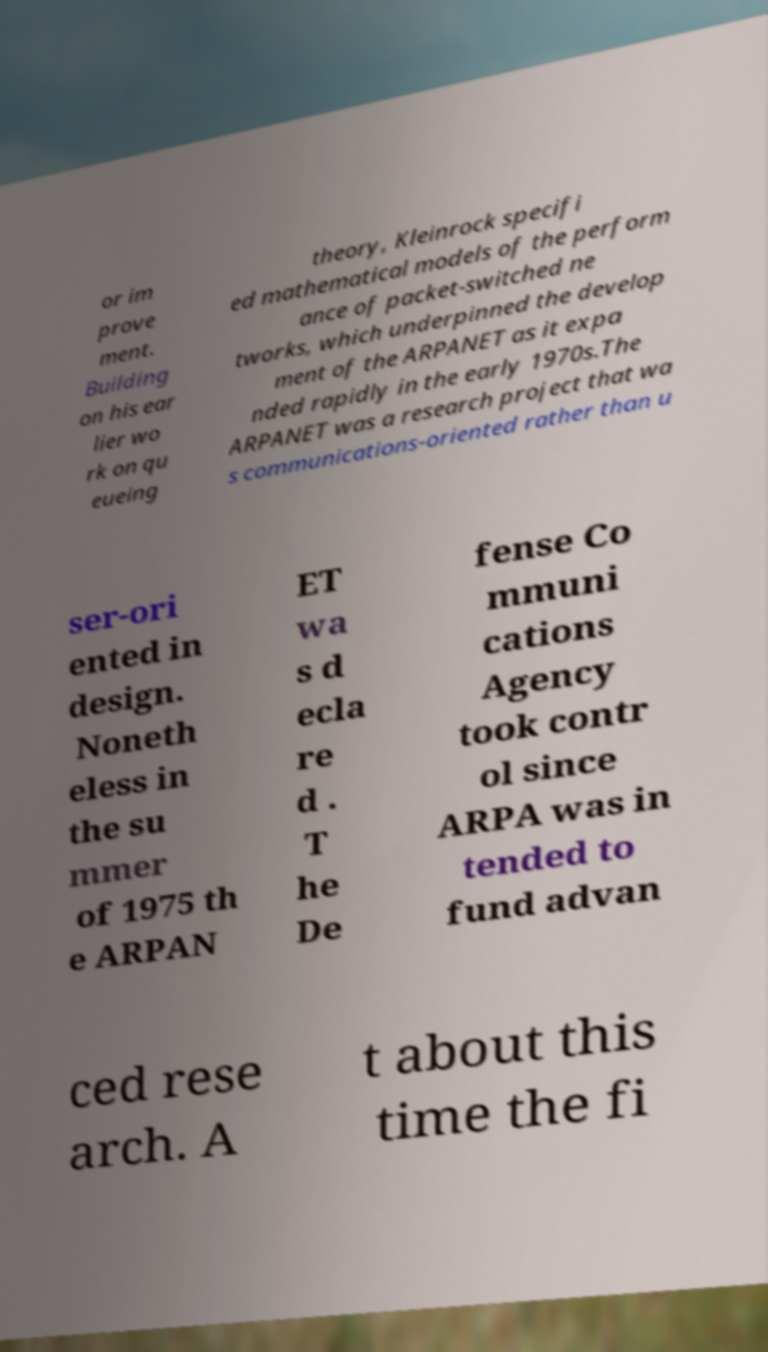For documentation purposes, I need the text within this image transcribed. Could you provide that? or im prove ment. Building on his ear lier wo rk on qu eueing theory, Kleinrock specifi ed mathematical models of the perform ance of packet-switched ne tworks, which underpinned the develop ment of the ARPANET as it expa nded rapidly in the early 1970s.The ARPANET was a research project that wa s communications-oriented rather than u ser-ori ented in design. Noneth eless in the su mmer of 1975 th e ARPAN ET wa s d ecla re d . T he De fense Co mmuni cations Agency took contr ol since ARPA was in tended to fund advan ced rese arch. A t about this time the fi 